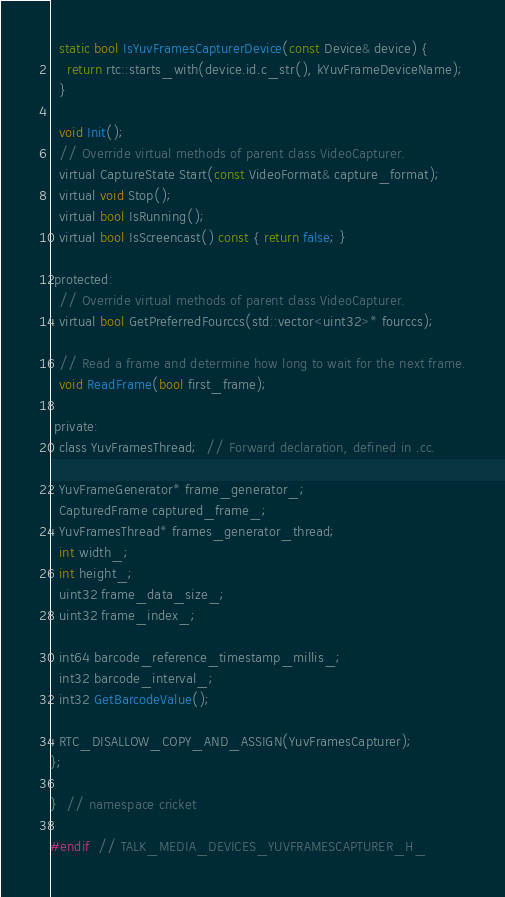Convert code to text. <code><loc_0><loc_0><loc_500><loc_500><_C_>  static bool IsYuvFramesCapturerDevice(const Device& device) {
    return rtc::starts_with(device.id.c_str(), kYuvFrameDeviceName);
  }

  void Init();
  // Override virtual methods of parent class VideoCapturer.
  virtual CaptureState Start(const VideoFormat& capture_format);
  virtual void Stop();
  virtual bool IsRunning();
  virtual bool IsScreencast() const { return false; }

 protected:
  // Override virtual methods of parent class VideoCapturer.
  virtual bool GetPreferredFourccs(std::vector<uint32>* fourccs);

  // Read a frame and determine how long to wait for the next frame.
  void ReadFrame(bool first_frame);

 private:
  class YuvFramesThread;  // Forward declaration, defined in .cc.

  YuvFrameGenerator* frame_generator_;
  CapturedFrame captured_frame_;
  YuvFramesThread* frames_generator_thread;
  int width_;
  int height_;
  uint32 frame_data_size_;
  uint32 frame_index_;

  int64 barcode_reference_timestamp_millis_;
  int32 barcode_interval_;
  int32 GetBarcodeValue();

  RTC_DISALLOW_COPY_AND_ASSIGN(YuvFramesCapturer);
};

}  // namespace cricket

#endif  // TALK_MEDIA_DEVICES_YUVFRAMESCAPTURER_H_
</code> 